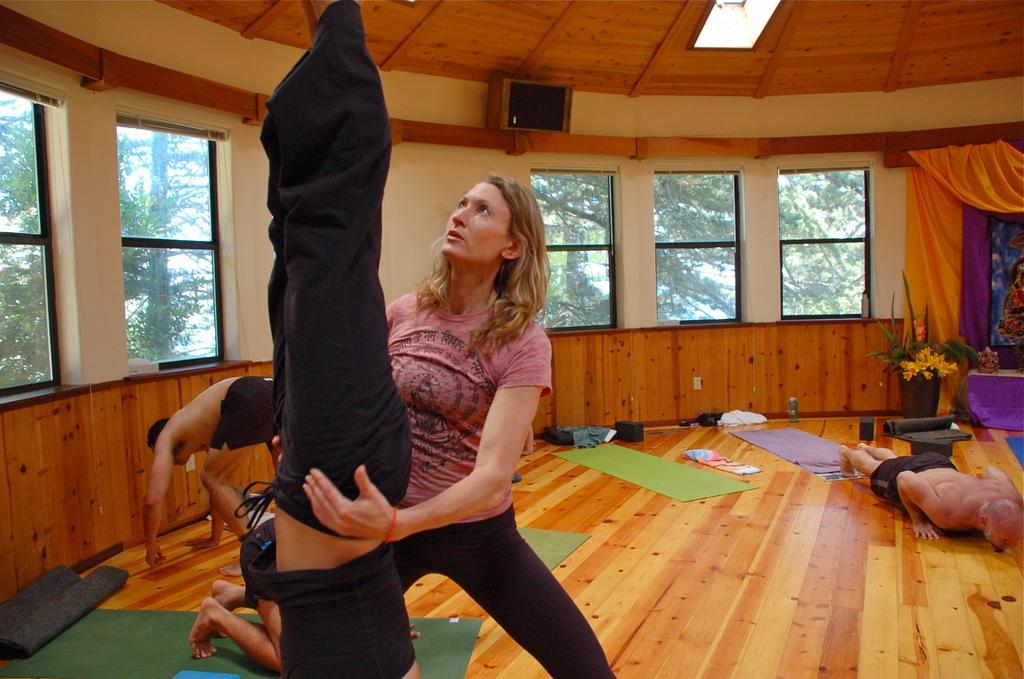Could you give a brief overview of what you see in this image? In this picture we can see few people are doing yoga, one woman is standing and watching, side we can see windows to the wall. 